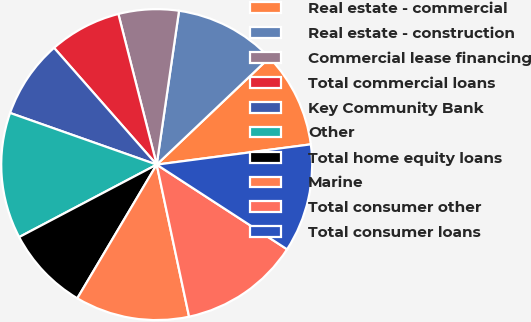Convert chart to OTSL. <chart><loc_0><loc_0><loc_500><loc_500><pie_chart><fcel>Real estate - commercial<fcel>Real estate - construction<fcel>Commercial lease financing<fcel>Total commercial loans<fcel>Key Community Bank<fcel>Other<fcel>Total home equity loans<fcel>Marine<fcel>Total consumer other<fcel>Total consumer loans<nl><fcel>10.0%<fcel>10.62%<fcel>6.26%<fcel>7.51%<fcel>8.13%<fcel>13.11%<fcel>8.75%<fcel>11.87%<fcel>12.49%<fcel>11.25%<nl></chart> 